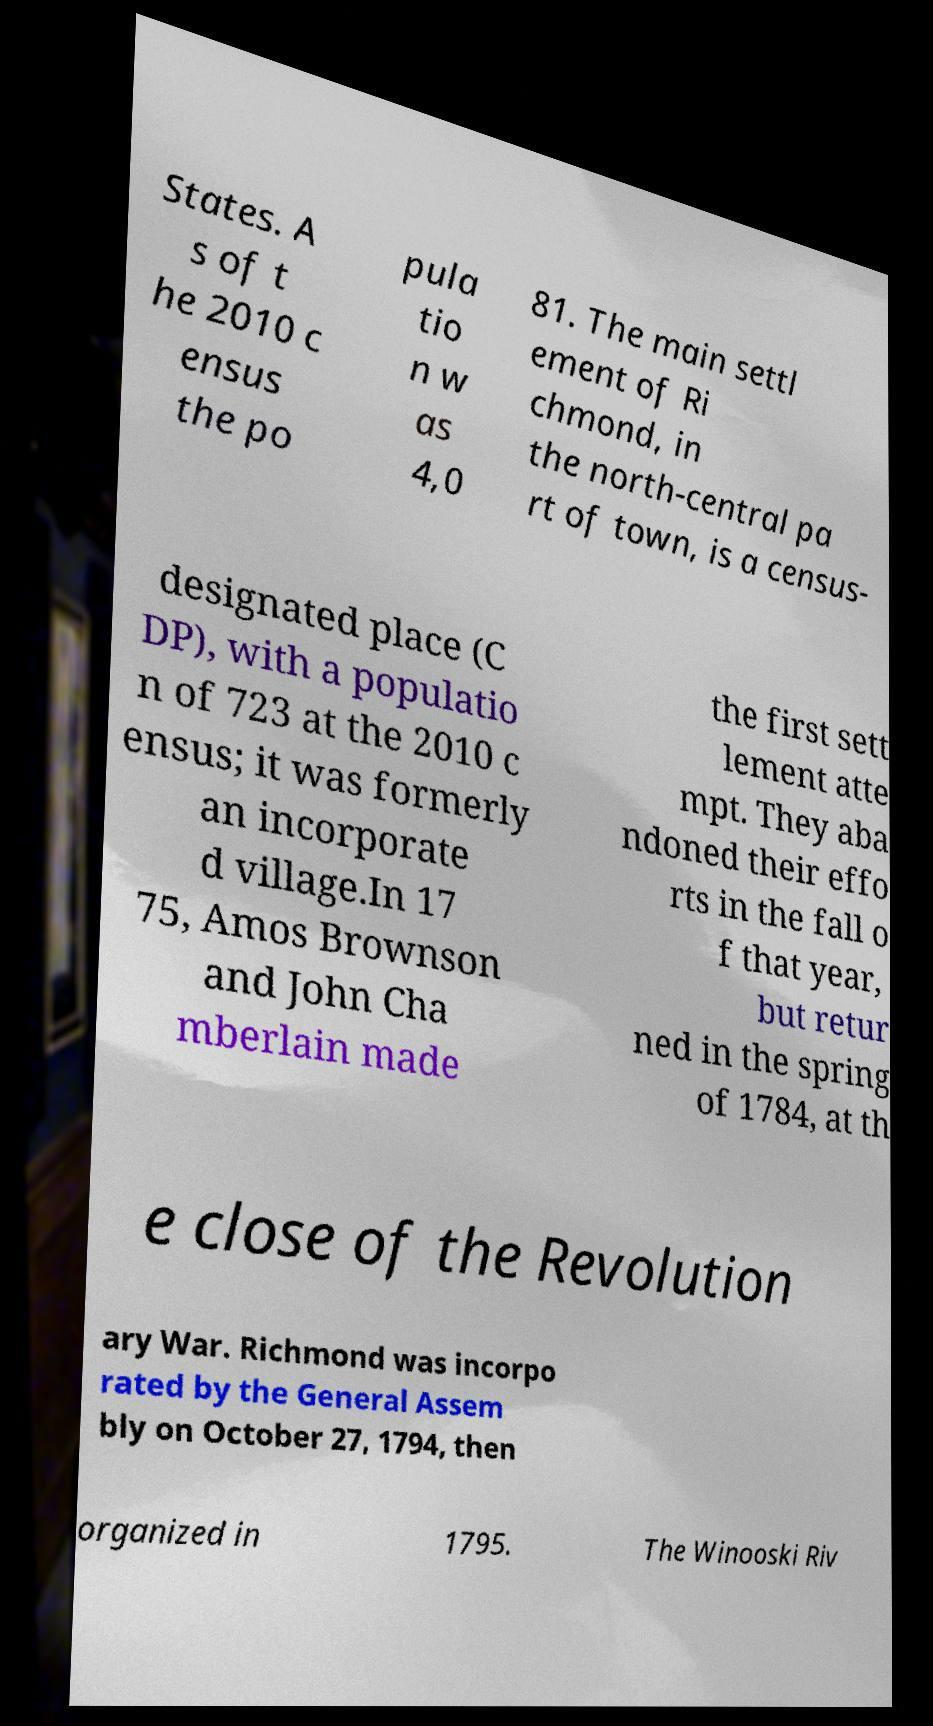Please read and relay the text visible in this image. What does it say? States. A s of t he 2010 c ensus the po pula tio n w as 4,0 81. The main settl ement of Ri chmond, in the north-central pa rt of town, is a census- designated place (C DP), with a populatio n of 723 at the 2010 c ensus; it was formerly an incorporate d village.In 17 75, Amos Brownson and John Cha mberlain made the first sett lement atte mpt. They aba ndoned their effo rts in the fall o f that year, but retur ned in the spring of 1784, at th e close of the Revolution ary War. Richmond was incorpo rated by the General Assem bly on October 27, 1794, then organized in 1795. The Winooski Riv 